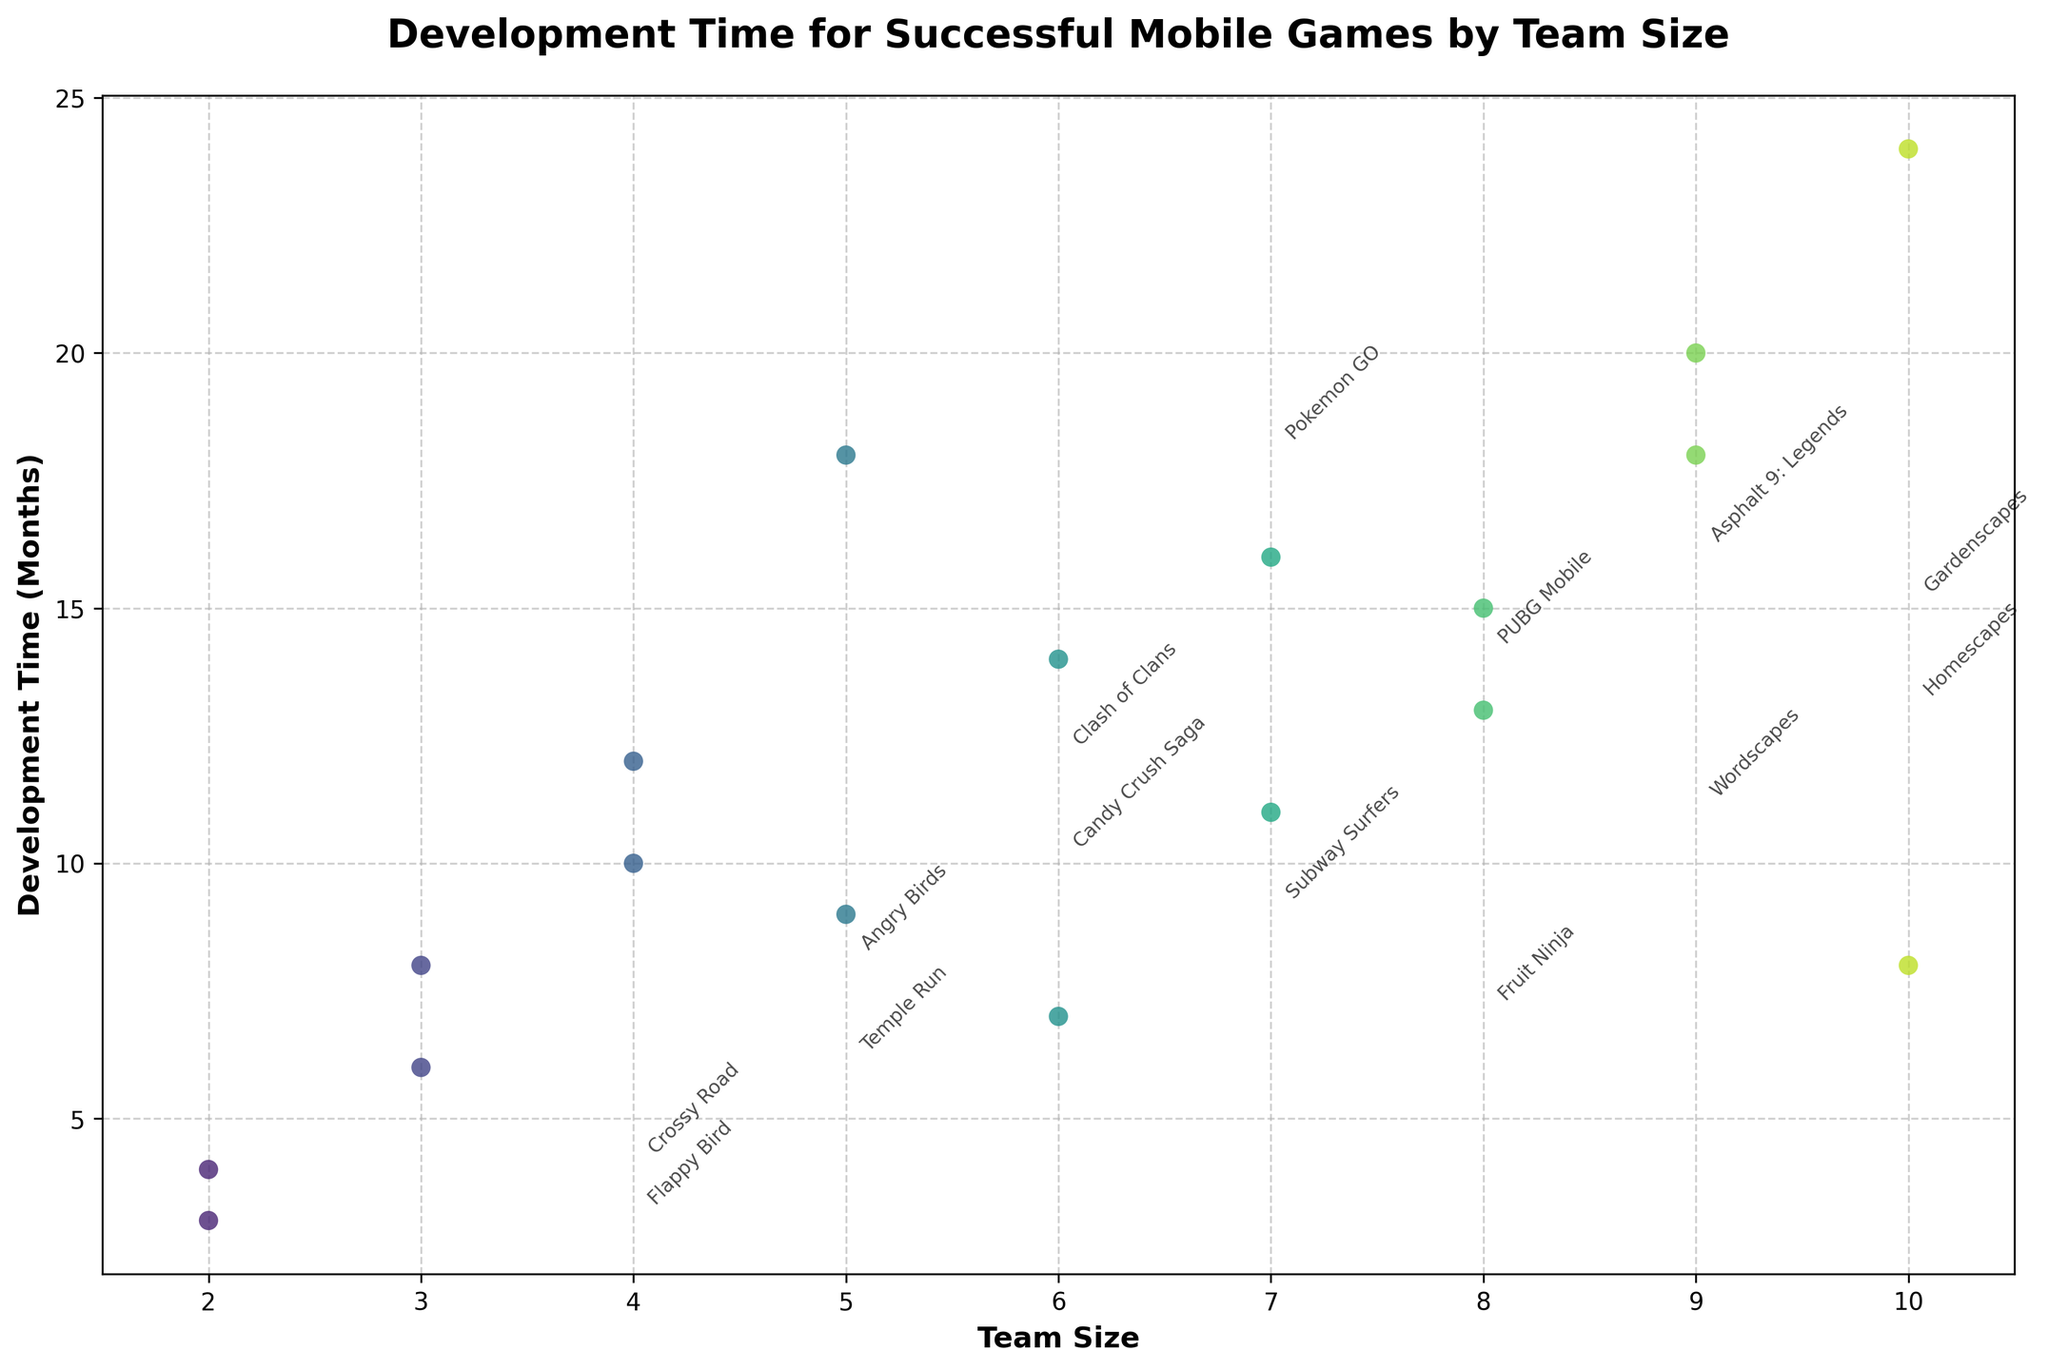What's the title of the figure? Look at the top of the plot to read its title.
Answer: Development Time for Successful Mobile Games by Team Size How many games were developed by teams of size 5? Identify the points above the x-axis label "5". Count these points.
Answer: 2 What is the highest development time depicted on the figure? Look for the point that reaches the maximum on the y-axis. The corresponding y-value is the highest development time.
Answer: 24 months Which game had the shortest development time? Identify the point that is at the lowest position on the y-axis and read the game name from the annotation.
Answer: Flappy Bird Which team size has the most diversity in development time? Compare the spread of points along the y-axis for each team size. Look for the x-axis label with the widest range of points.
Answer: Team size 5 What is the average development time for games made by teams of size 6? Identify the points above x-axis label "6". Add the y-values (development times) and divide by the number of points. (14 + 7) / 2 = 21 / 2
Answer: 10.5 months How does the development time for Candy Crush Saga compare to that for Clash of Clans? Find the points and corresponding y-values for Candy Crush Saga and Clash of Clans. Compare these y-values.
Answer: Candy Crush Saga took 2 months less than Clash of Clans Which game had the longest development time among those created by a team of size 10? Locate the points above x-axis label "10". Identify the highest point and read the game name from the annotation.
Answer: Genshin Impact What's the median development time for team size 8? Identify the points above x-axis label "8". Arrange their y-values in ascending order and find the middle value. (13, 15) The median is the first value in this case since there are two data points.
Answer: 14 months Do all team sizes develop a game in less than 25 months? Inspect the y-values for all points across different team sizes. Check if any point exceeds 25 months.
Answer: Yes 